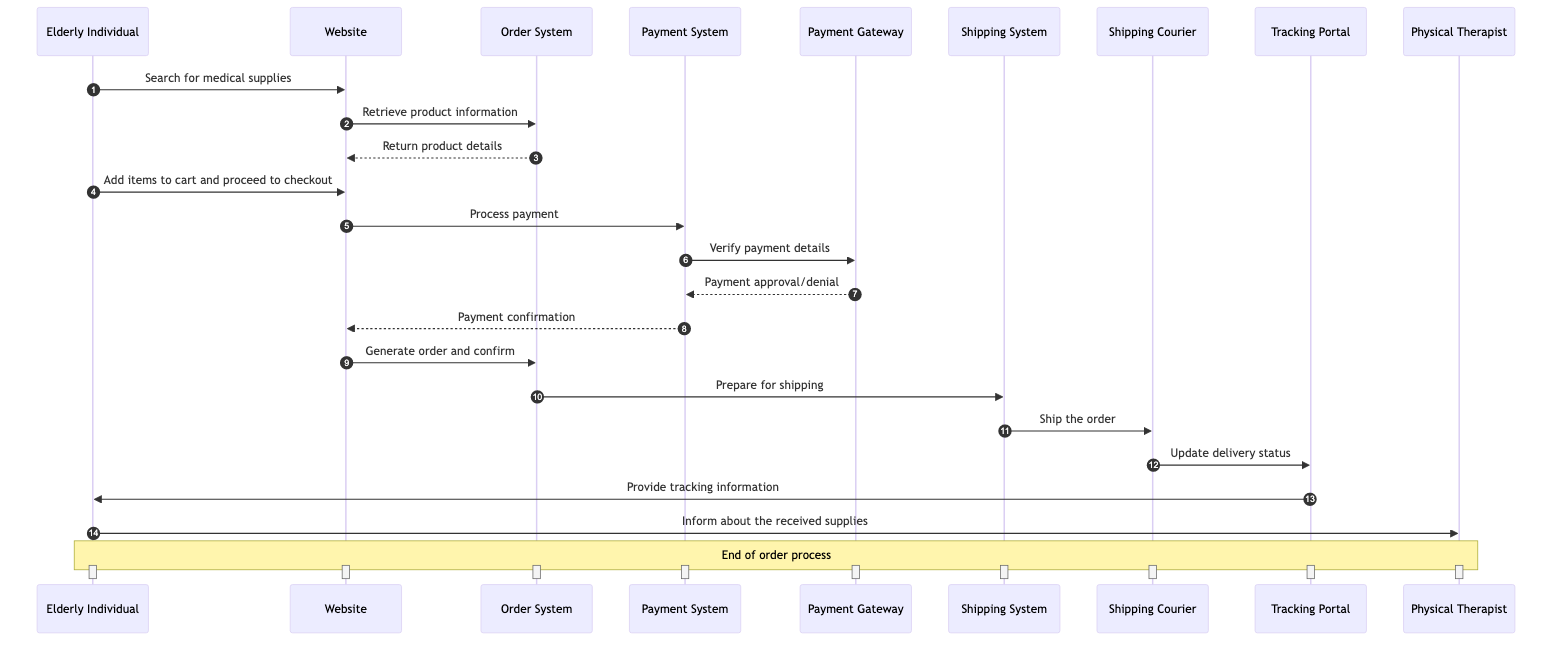What are the main actors involved in the ordering process? The diagram lists five actors: Elderly Individual, Online Medical Supply Store, Payment Gateway, Shipping Courier, and Physical Therapist. These are the entities interacting to complete the order.
Answer: Elderly Individual, Online Medical Supply Store, Payment Gateway, Shipping Courier, Physical Therapist What is the first action taken by the Elderly Individual? The Elderly Individual initiates the process by searching for medical supplies on the Website. This is the very first message in the sequence diagram.
Answer: Search for medical supplies How many systems are utilized in the ordering and delivery process? There are four systems in total involved: Order System, Payment System, Shipping System, and Tracking Portal. These systems facilitate the processing and tracking of the order.
Answer: Four What type of message is sent from the Order System to the Shipping System? The message from the Order System to the Shipping System is a request to prepare for shipping. This indicates a specific action that needs to be done as part of the order fulfillment process.
Answer: Request Who provides the payment confirmation to the Website? The Payment System returns the payment confirmation to the Website after processing the payment. This step is crucial as it allows the order to move forward once the payment is verified.
Answer: Payment System What occurs after the Shipping Courier updates the delivery status? After updating the delivery status to the Tracking Portal, the Tracking Portal then provides tracking information to the Elderly Individual, allowing them to see the delivery progress. This step ensures the customer remains informed about their order's status.
Answer: Provide tracking information Which actor is informed about the received supplies? The Elderly Individual informs the Physical Therapist about the received supplies after successfully receiving the order. This indicates the final communication step after delivery.
Answer: Physical Therapist How many notification or update messages are sent to the Elderly Individual? The Elderly Individual receives two messages: one from the Tracking Portal providing tracking information and another from the Physical Therapist informed about the received supplies. These interactions highlight the feedback loops occurring after the order is placed.
Answer: Two What is the final outcome of the order process as shown in the diagram? The final outcome is the Elderly Individual informing the Physical Therapist about the received supplies, signifying that the whole order process, from searching to delivery, has been completed successfully.
Answer: Inform about the received supplies 